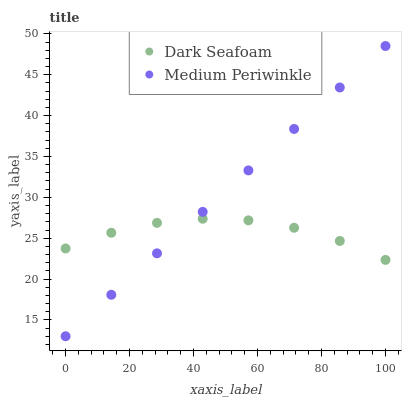Does Dark Seafoam have the minimum area under the curve?
Answer yes or no. Yes. Does Medium Periwinkle have the maximum area under the curve?
Answer yes or no. Yes. Does Medium Periwinkle have the minimum area under the curve?
Answer yes or no. No. Is Medium Periwinkle the smoothest?
Answer yes or no. Yes. Is Dark Seafoam the roughest?
Answer yes or no. Yes. Is Medium Periwinkle the roughest?
Answer yes or no. No. Does Medium Periwinkle have the lowest value?
Answer yes or no. Yes. Does Medium Periwinkle have the highest value?
Answer yes or no. Yes. Does Medium Periwinkle intersect Dark Seafoam?
Answer yes or no. Yes. Is Medium Periwinkle less than Dark Seafoam?
Answer yes or no. No. Is Medium Periwinkle greater than Dark Seafoam?
Answer yes or no. No. 